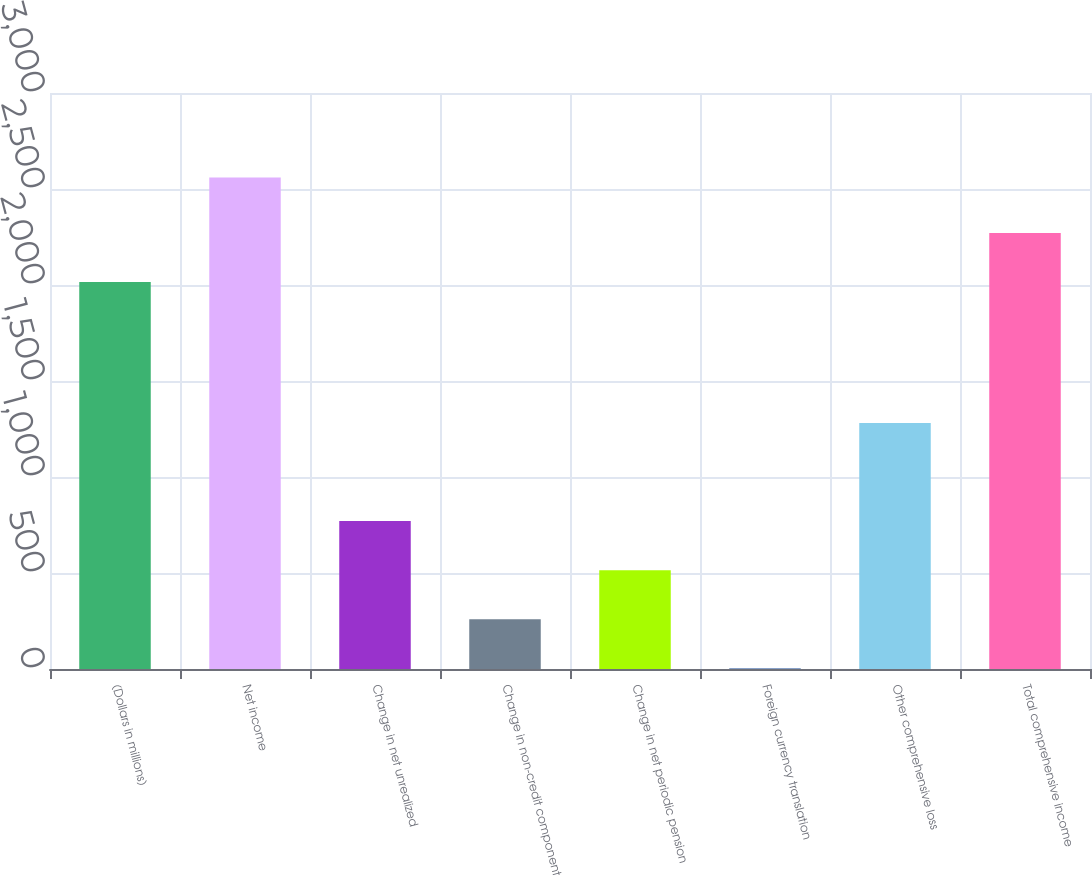Convert chart. <chart><loc_0><loc_0><loc_500><loc_500><bar_chart><fcel>(Dollars in millions)<fcel>Net income<fcel>Change in net unrealized<fcel>Change in non-credit component<fcel>Change in net periodic pension<fcel>Foreign currency translation<fcel>Other comprehensive loss<fcel>Total comprehensive income<nl><fcel>2015<fcel>2560<fcel>770.38<fcel>259.06<fcel>514.72<fcel>3.4<fcel>1281.7<fcel>2270.66<nl></chart> 